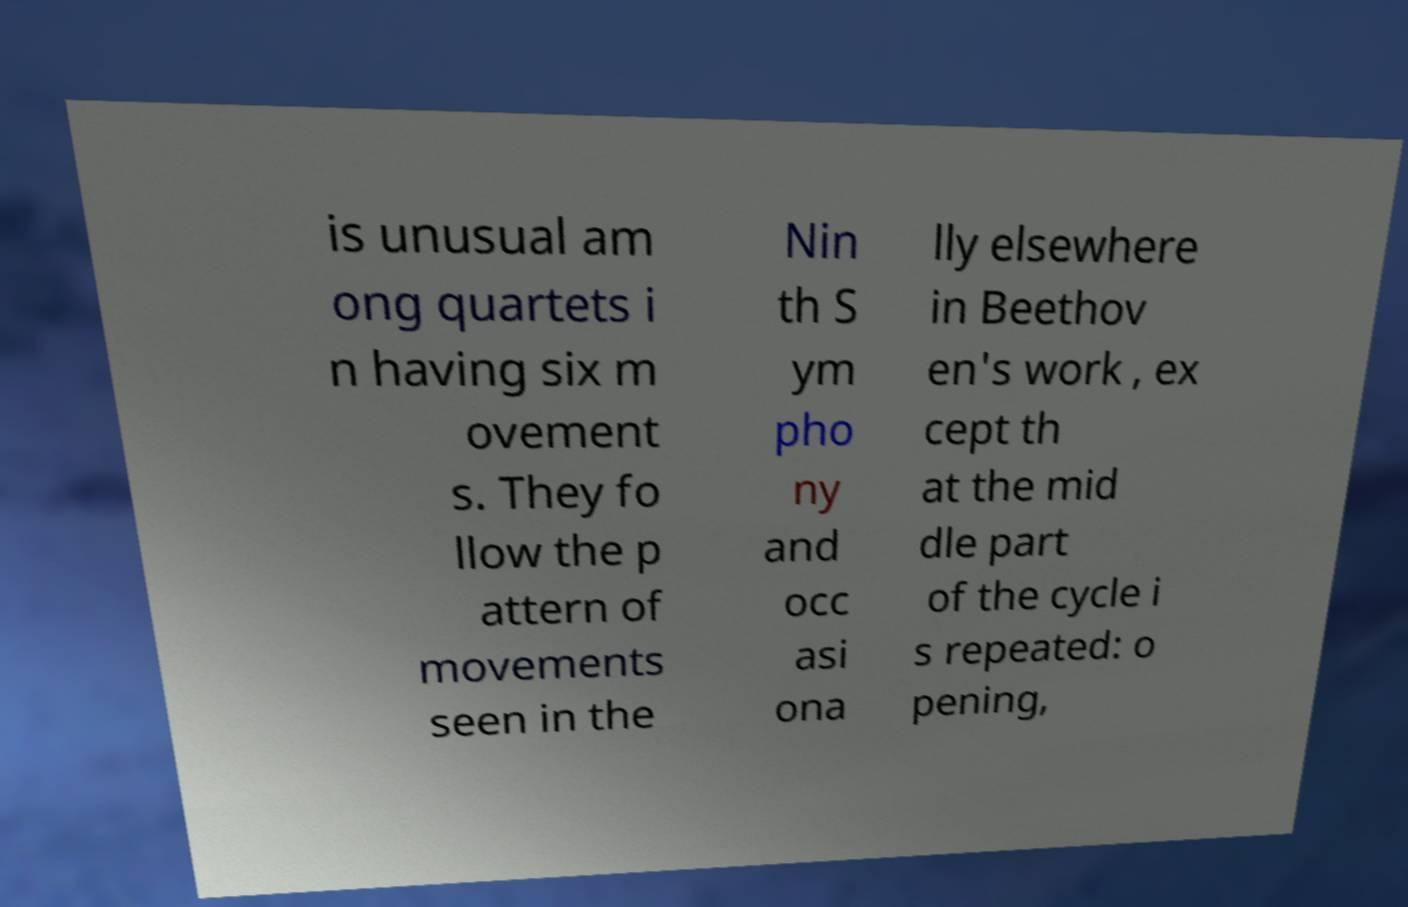Please identify and transcribe the text found in this image. is unusual am ong quartets i n having six m ovement s. They fo llow the p attern of movements seen in the Nin th S ym pho ny and occ asi ona lly elsewhere in Beethov en's work , ex cept th at the mid dle part of the cycle i s repeated: o pening, 